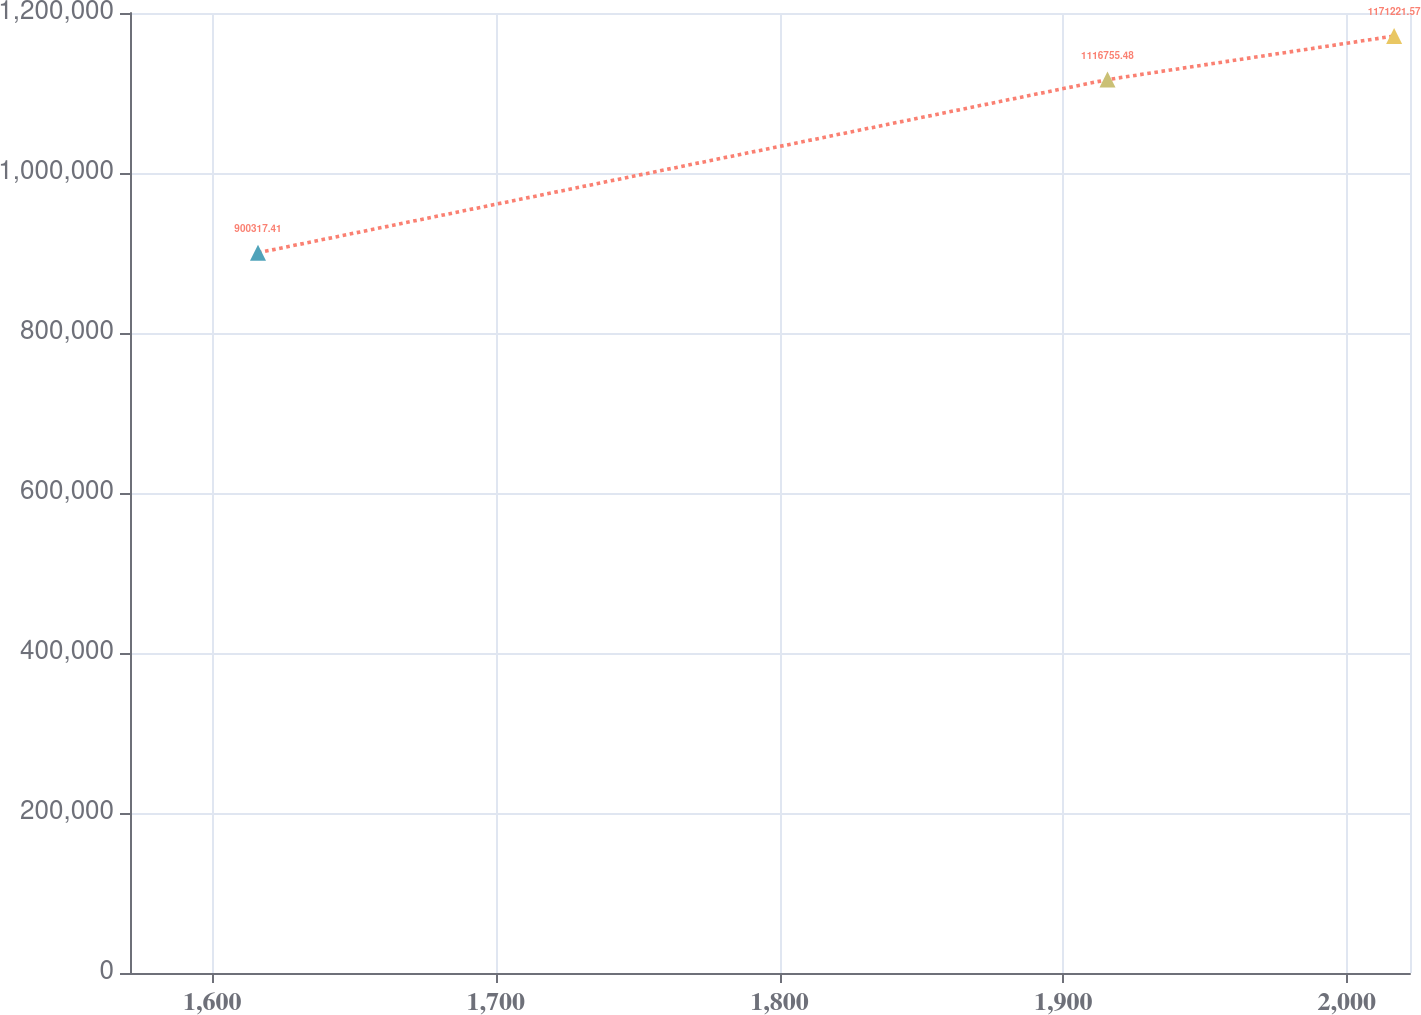Convert chart. <chart><loc_0><loc_0><loc_500><loc_500><line_chart><ecel><fcel>Unnamed: 1<nl><fcel>1616.14<fcel>900317<nl><fcel>1915.63<fcel>1.11676e+06<nl><fcel>2016.68<fcel>1.17122e+06<nl><fcel>2067.41<fcel>1.44498e+06<nl></chart> 